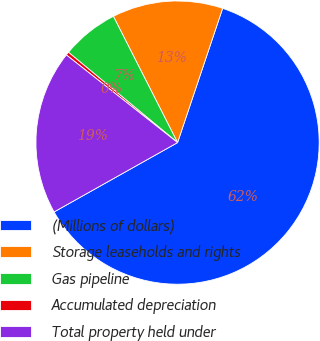Convert chart. <chart><loc_0><loc_0><loc_500><loc_500><pie_chart><fcel>(Millions of dollars)<fcel>Storage leaseholds and rights<fcel>Gas pipeline<fcel>Accumulated depreciation<fcel>Total property held under<nl><fcel>61.7%<fcel>12.64%<fcel>6.51%<fcel>0.38%<fcel>18.77%<nl></chart> 